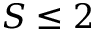<formula> <loc_0><loc_0><loc_500><loc_500>S \leq 2</formula> 